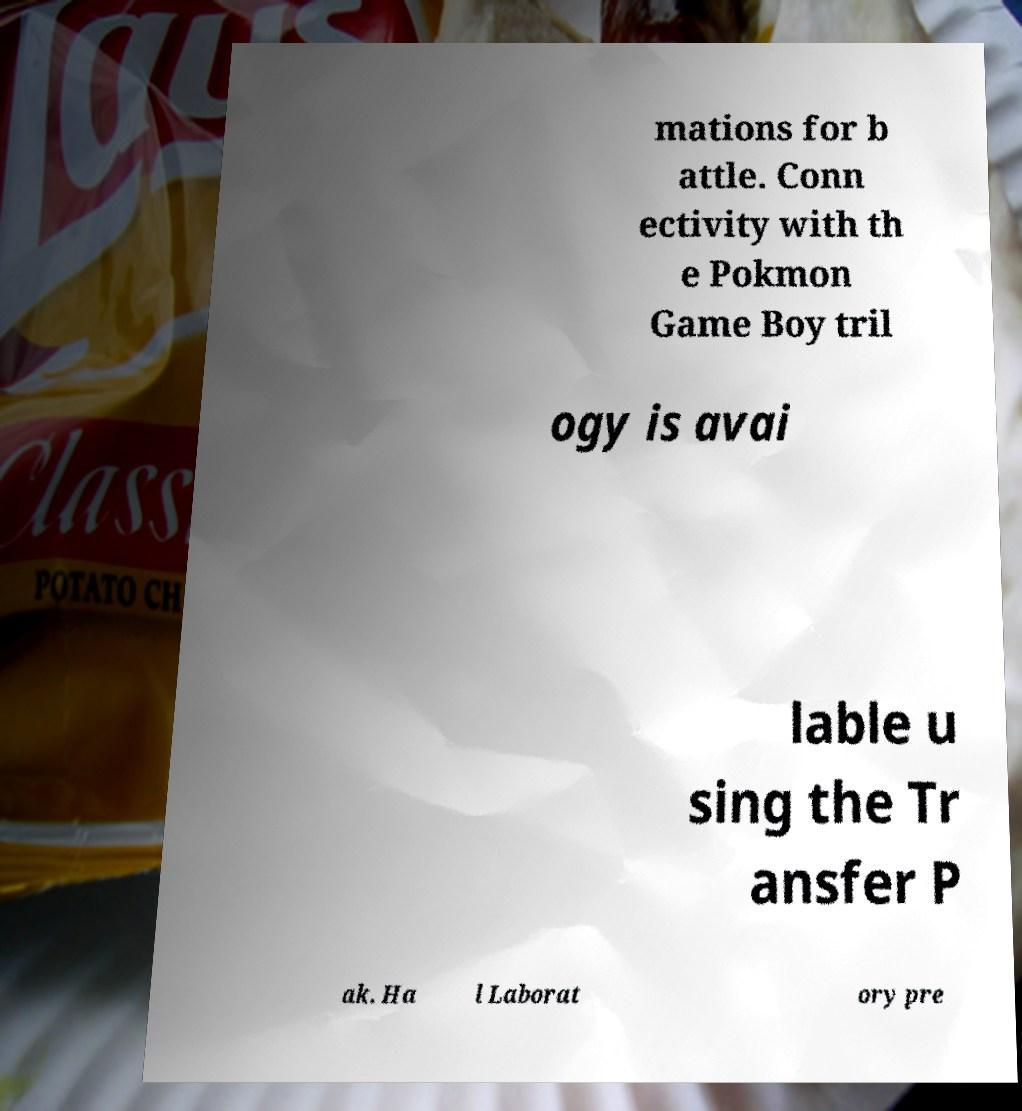Could you extract and type out the text from this image? mations for b attle. Conn ectivity with th e Pokmon Game Boy tril ogy is avai lable u sing the Tr ansfer P ak. Ha l Laborat ory pre 